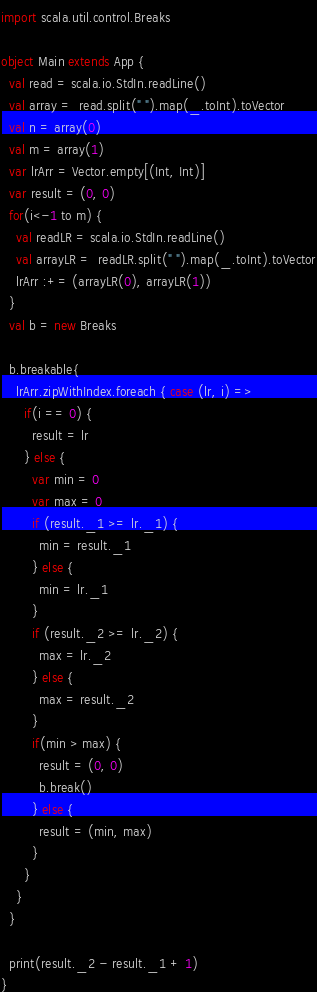<code> <loc_0><loc_0><loc_500><loc_500><_Scala_>import scala.util.control.Breaks

object Main extends App {
  val read = scala.io.StdIn.readLine()
  val array =  read.split(" ").map(_.toInt).toVector
  val n = array(0)
  val m = array(1)
  var lrArr = Vector.empty[(Int, Int)]
  var result = (0, 0)
  for(i<-1 to m) {
    val readLR = scala.io.StdIn.readLine()
    val arrayLR =  readLR.split(" ").map(_.toInt).toVector
    lrArr :+= (arrayLR(0), arrayLR(1))
  }
  val b = new Breaks

  b.breakable{
    lrArr.zipWithIndex.foreach { case (lr, i) =>
      if(i == 0) {
        result = lr
      } else {
        var min = 0
        var max = 0
        if (result._1 >= lr._1) {
          min = result._1
        } else {
          min = lr._1
        }
        if (result._2 >= lr._2) {
          max = lr._2
        } else {
          max = result._2
        }
        if(min > max) {
          result = (0, 0)
          b.break()
        } else {
          result = (min, max)
        }
      }
    }
  }

  print(result._2 - result._1 + 1)
}</code> 